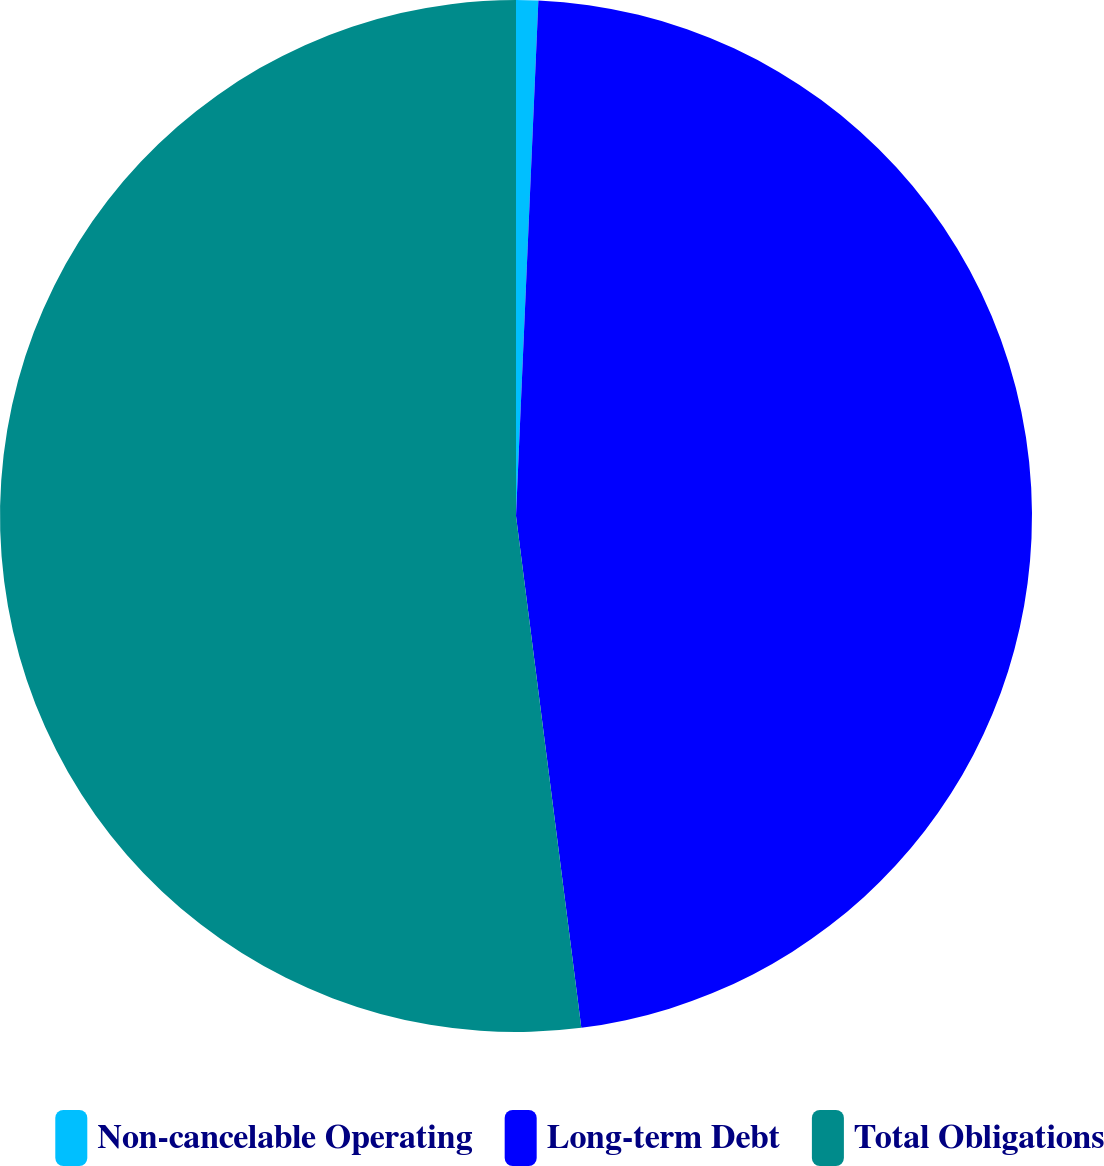Convert chart. <chart><loc_0><loc_0><loc_500><loc_500><pie_chart><fcel>Non-cancelable Operating<fcel>Long-term Debt<fcel>Total Obligations<nl><fcel>0.69%<fcel>47.29%<fcel>52.02%<nl></chart> 